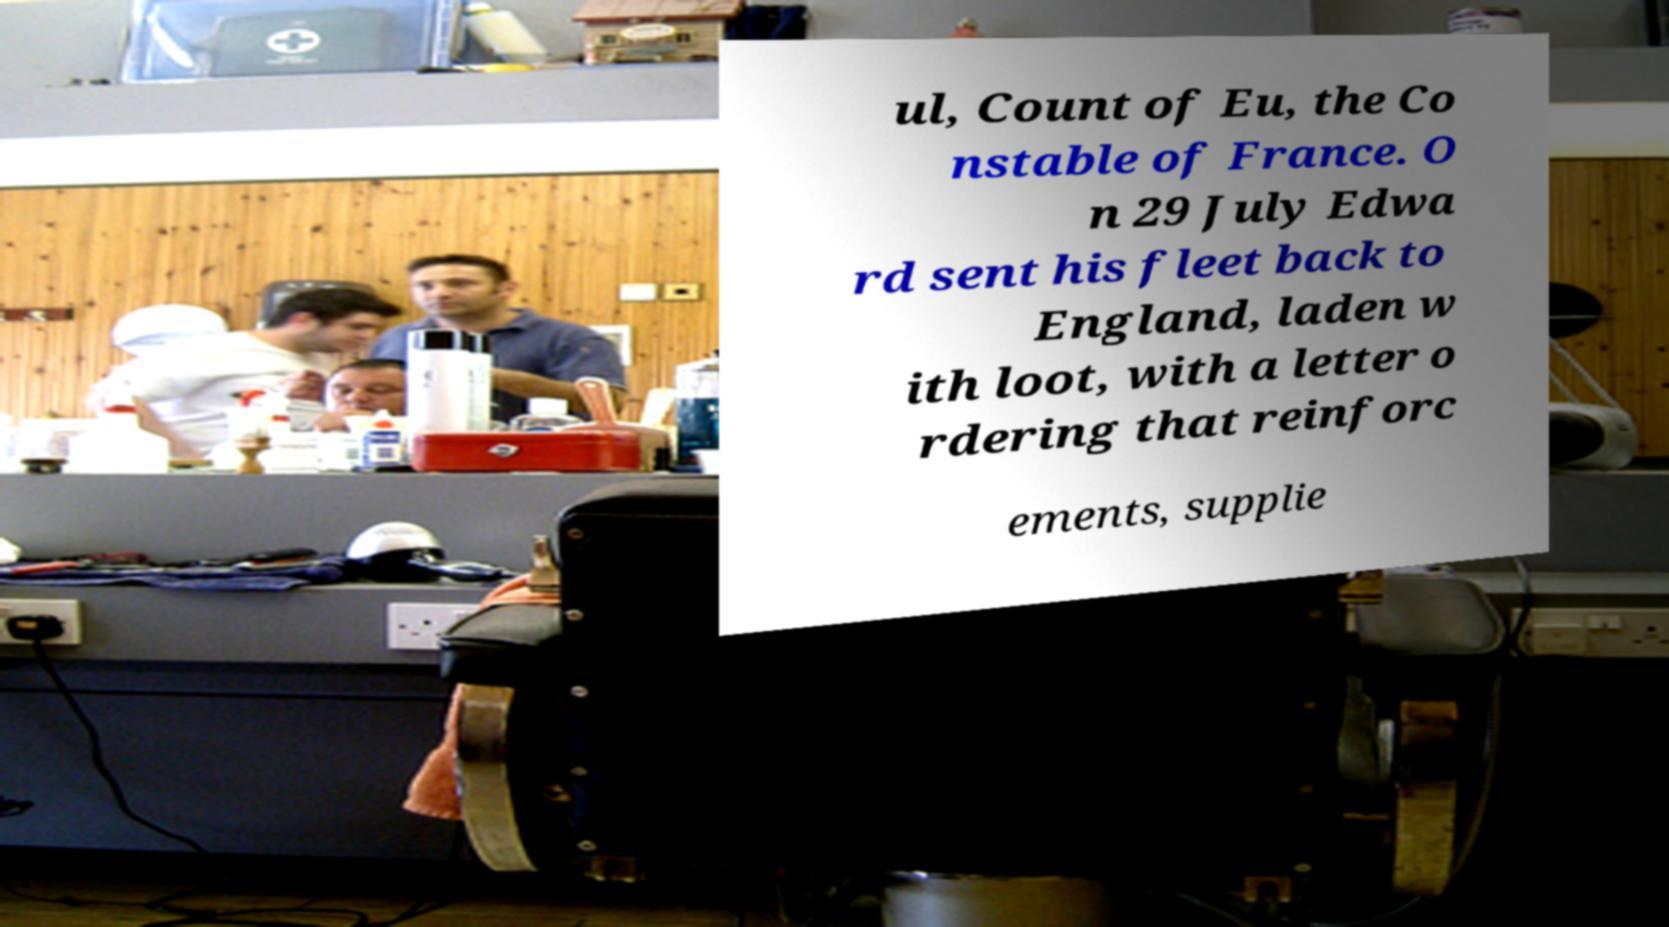Could you extract and type out the text from this image? ul, Count of Eu, the Co nstable of France. O n 29 July Edwa rd sent his fleet back to England, laden w ith loot, with a letter o rdering that reinforc ements, supplie 